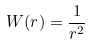Convert formula to latex. <formula><loc_0><loc_0><loc_500><loc_500>W ( { r } ) = \frac { 1 } { r ^ { 2 } } \,</formula> 